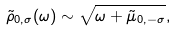Convert formula to latex. <formula><loc_0><loc_0><loc_500><loc_500>\tilde { \rho } _ { 0 , \sigma } ( \omega ) \sim { \sqrt { \omega + \tilde { \mu } _ { 0 , - \sigma } } } ,</formula> 